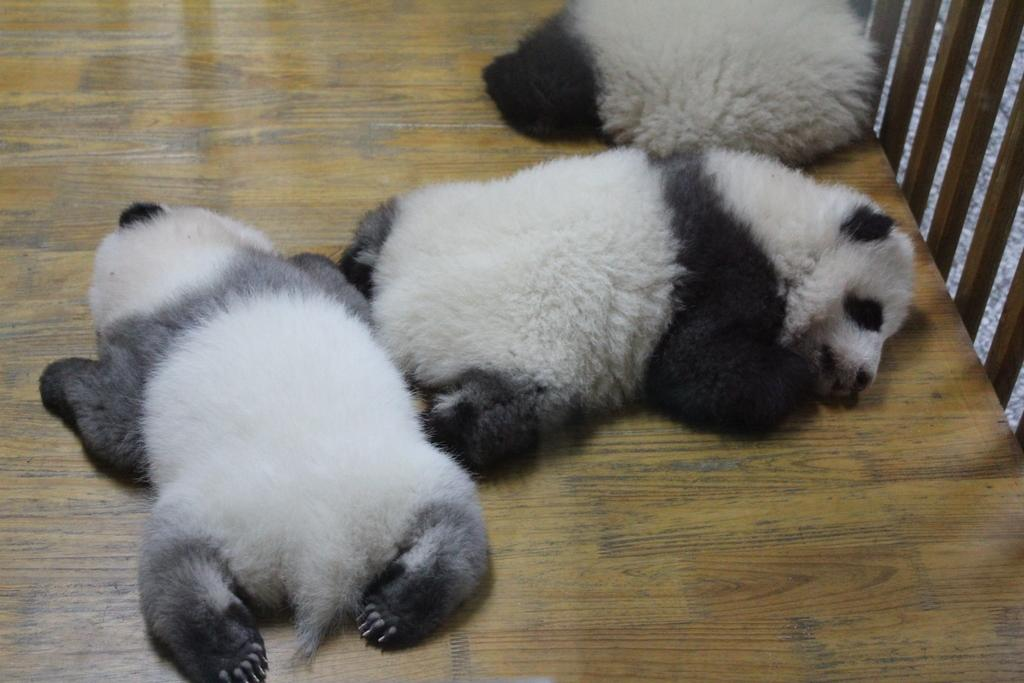What are the animals doing in the image? The animals are sleeping on the floor in the image. Can you describe any specific features of the image's setting? There is a wooden railing on the right side of the image. What direction are the animals facing while they are sleeping in the image? The provided facts do not specify the direction the animals are facing while sleeping. --- Facts: 1. There is a person sitting on a chair in the image. 2. The person is holding a book. 3. There is a table next to the chair. 4. There is a lamp on the table. Absurd Topics: parrot, ocean, bicycle Conversation: What is the person in the image doing? The person is sitting on a chair in the image. What object is the person holding? The person is holding a book. Can you describe any furniture or objects near the person? There is a table next to the chair, and there is a lamp on the table. Reasoning: Let's think step by step in order to produce the conversation. We start by identifying the main subject in the image, which is the person sitting on a chair. Then, we expand the conversation to include other items that are also visible, such as the book, table, and lamp. Each question is designed to elicit a specific detail about the image that is known from the provided facts. Absurd Question/Answer: Can you see a parrot sitting on the person's shoulder in the image? No, there is no parrot visible in the image. What type of ocean can be seen in the background of the image? There is no ocean present in the image; it features a person sitting on a chair with a book, a table, and a lamp. 